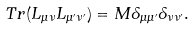<formula> <loc_0><loc_0><loc_500><loc_500>T r ( L _ { \mu \nu } L _ { \mu ^ { \prime } \nu ^ { \prime } } ) = M \delta _ { \mu \mu ^ { \prime } } \delta _ { \nu \nu ^ { \prime } } .</formula> 